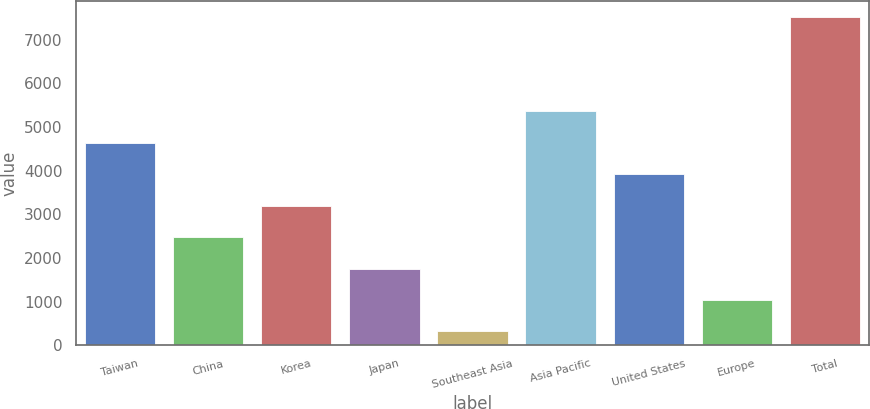Convert chart. <chart><loc_0><loc_0><loc_500><loc_500><bar_chart><fcel>Taiwan<fcel>China<fcel>Korea<fcel>Japan<fcel>Southeast Asia<fcel>Asia Pacific<fcel>United States<fcel>Europe<fcel>Total<nl><fcel>4633.4<fcel>2476.7<fcel>3195.6<fcel>1757.8<fcel>320<fcel>5356<fcel>3914.5<fcel>1038.9<fcel>7509<nl></chart> 